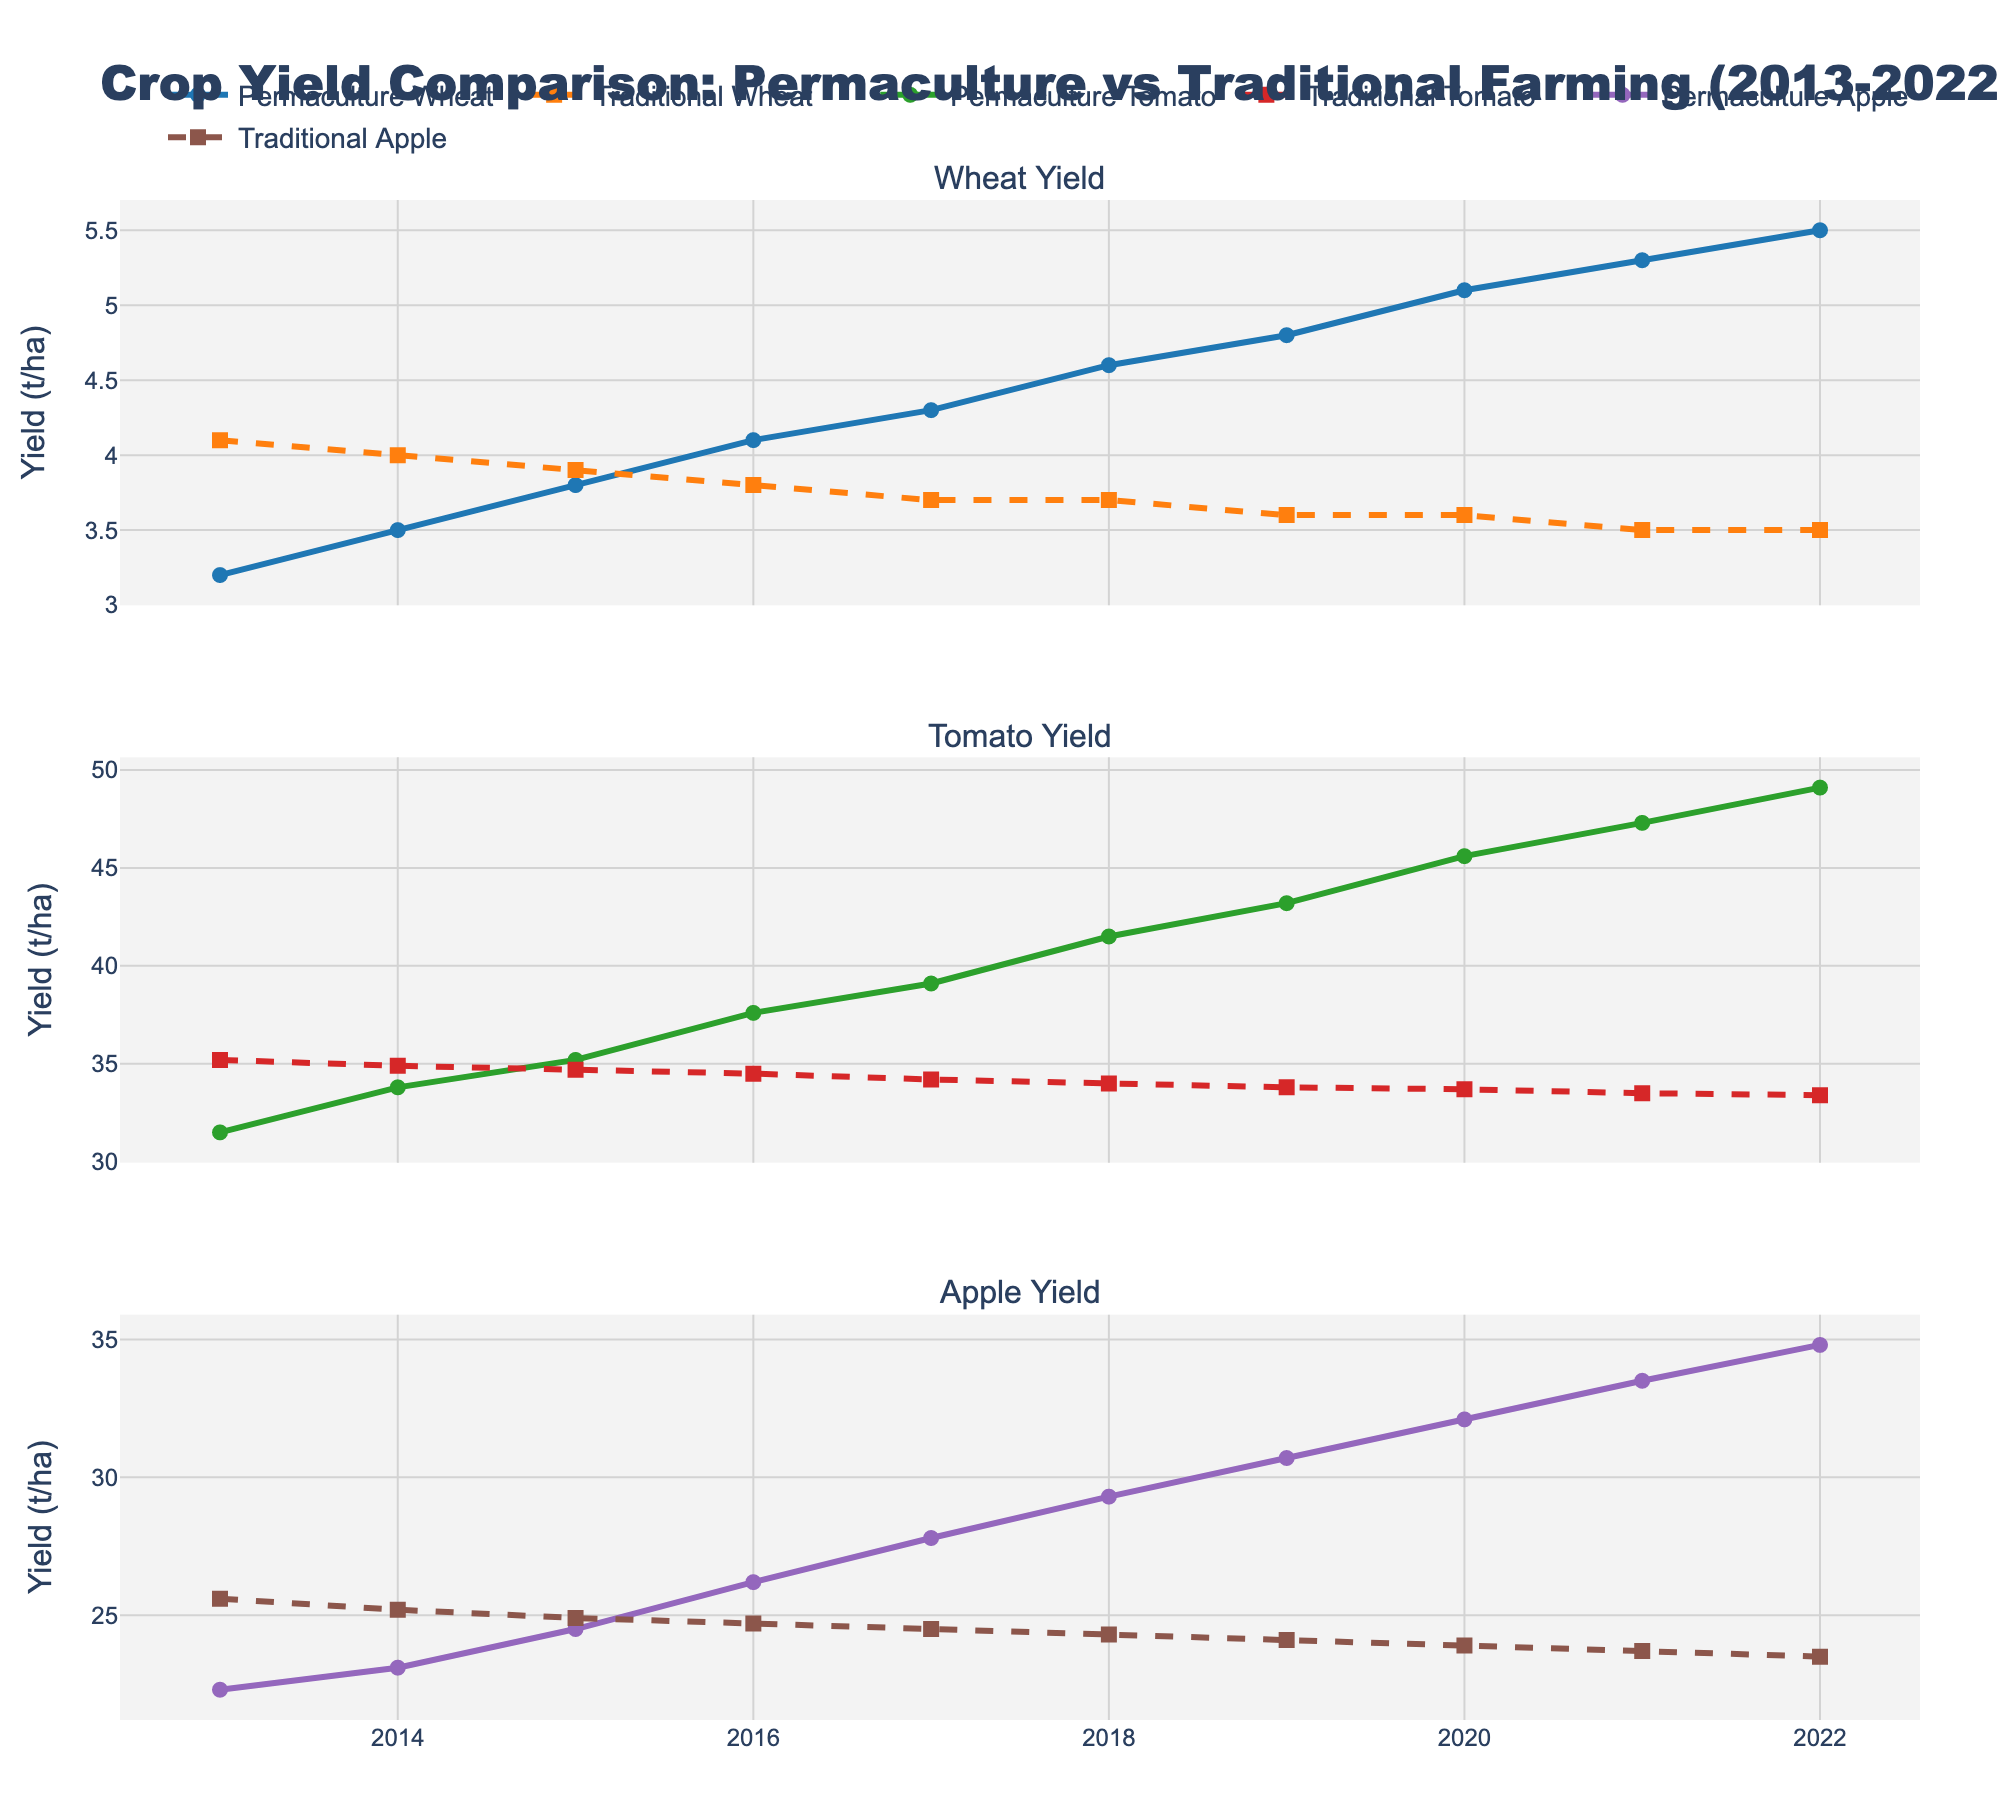What's the overall trend in wheat yield for permaculture and traditional farming from 2013 to 2022? The figure shows an upward trend for permaculture wheat yield, starting at 3.2 t/ha in 2013 and rising to 5.5 t/ha in 2022. Conversely, traditional wheat yield shows a downward trend, starting at 4.1 t/ha in 2013 and decreasing to 3.5 t/ha in 2022.
Answer: Permaculture: Upward, Traditional: Downward In 2018, how does the permaculture yield of tomatoes compare to the traditional yield? Looking at the tomato yield data in 2018, the permaculture yield is 41.5 t/ha, whereas the traditional yield is 34.0 t/ha. Comparing these values, permaculture exceeds traditional yield.
Answer: Permaculture is higher by 7.5 t/ha Which year had the largest difference in wheat yield between permaculture and traditional farming? By inspecting the wheat yields, the largest difference occurs in 2022 where permaculture yield was 5.5 t/ha and traditional yield was 3.5 t/ha, resulting in a difference of 2 t/ha.
Answer: 2022 What is the percentage increase in permaculture apple yield from 2013 to 2022? The permaculture apple yield in 2013 is 22.3 t/ha and in 2022 it is 34.8 t/ha. The percentage increase is calculated as \((34.8 - 22.3) / 22.3 \times 100 = 56.1\%\).
Answer: 56.1% On average, how do permaculture and traditional farming yields of tomatoes compare over the 10-year period? Calculate the average of permaculture tomato yields from 2013 to 2022: \((31.5 + 33.8 + 35.2 + 37.6 + 39.1 + 41.5 + 43.2 + 45.6 + 47.3 + 49.1) / 10 = 40.39\) t/ha. For traditional, it's \((35.2 + 34.9 + 34.7 + 34.5 + 34.2 + 34.0 + 33.8 + 33.7 + 33.5 + 33.4) / 10 = 34.29\) t/ha. Thus, on average, permaculture yield is higher by 6.1 t/ha.
Answer: Permaculture: 40.39 t/ha, Traditional: 34.29 t/ha In which year did permaculture apple yields surpass traditional apple yields, and by how much? In 2015, permaculture apple yield was 24.5 t/ha while traditional was 24.9 t/ha (perm.* lower). In 2016, permaculture apple yield was 26.2 t/ha whereas traditional was 24.7 t/ha. Thus, it surpassed in 2016 by \(26.2 - 24.7 = 1.5\) t/ha.
Answer: 2016, by 1.5 t/ha What visual pattern can be observed in the line styles for permaculture and traditional farming across crops? The permaculture yields are represented by solid lines with markers, while traditional yields are shown with dashed lines with markers. This pattern is consistent for wheat, tomato, and apple across the figure.
Answer: Solid vs. dashed lines How does the permaculture wheat yield in 2013 compare to the traditional wheat yield in 2022? The permaculture wheat yield in 2013 is 3.2 t/ha, whereas the traditional wheat yield in 2022 is 3.5 t/ha. The traditional yield in 2022 is slightly higher by 0.3 t/ha.
Answer: Traditional higher by 0.3 t/ha From which year does the permaculture yield consistently exceed 4 t/ha for tomatoes? By inspecting the permaculture tomato yield data, it exceeds 4 t/ha from 2016 onwards continuously.
Answer: From 2016 